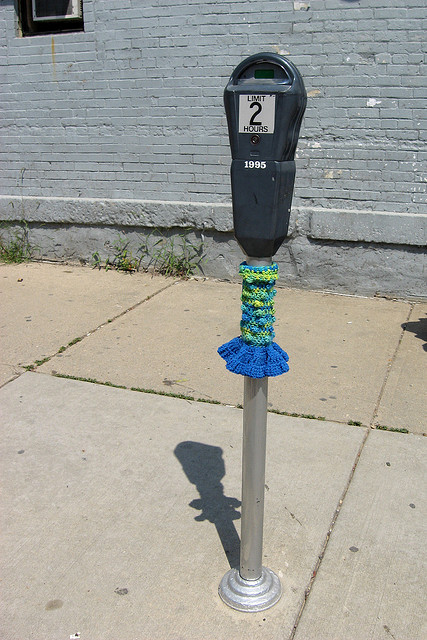<image>How much time is left on the meter? It is unknown how much time is left on the meter. It cannot be seen clearly. How much time is left on the meter? I'm not sure how much time is left on the meter. It can be seen as '2 hours', '2 minutes', or '38 minutes'. 